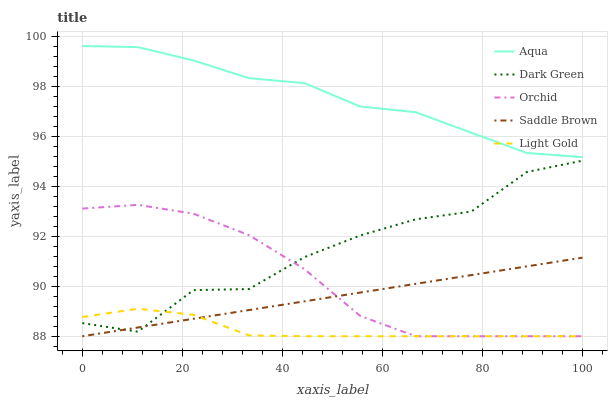Does Orchid have the minimum area under the curve?
Answer yes or no. No. Does Orchid have the maximum area under the curve?
Answer yes or no. No. Is Orchid the smoothest?
Answer yes or no. No. Is Orchid the roughest?
Answer yes or no. No. Does Aqua have the lowest value?
Answer yes or no. No. Does Orchid have the highest value?
Answer yes or no. No. Is Orchid less than Aqua?
Answer yes or no. Yes. Is Aqua greater than Light Gold?
Answer yes or no. Yes. Does Orchid intersect Aqua?
Answer yes or no. No. 